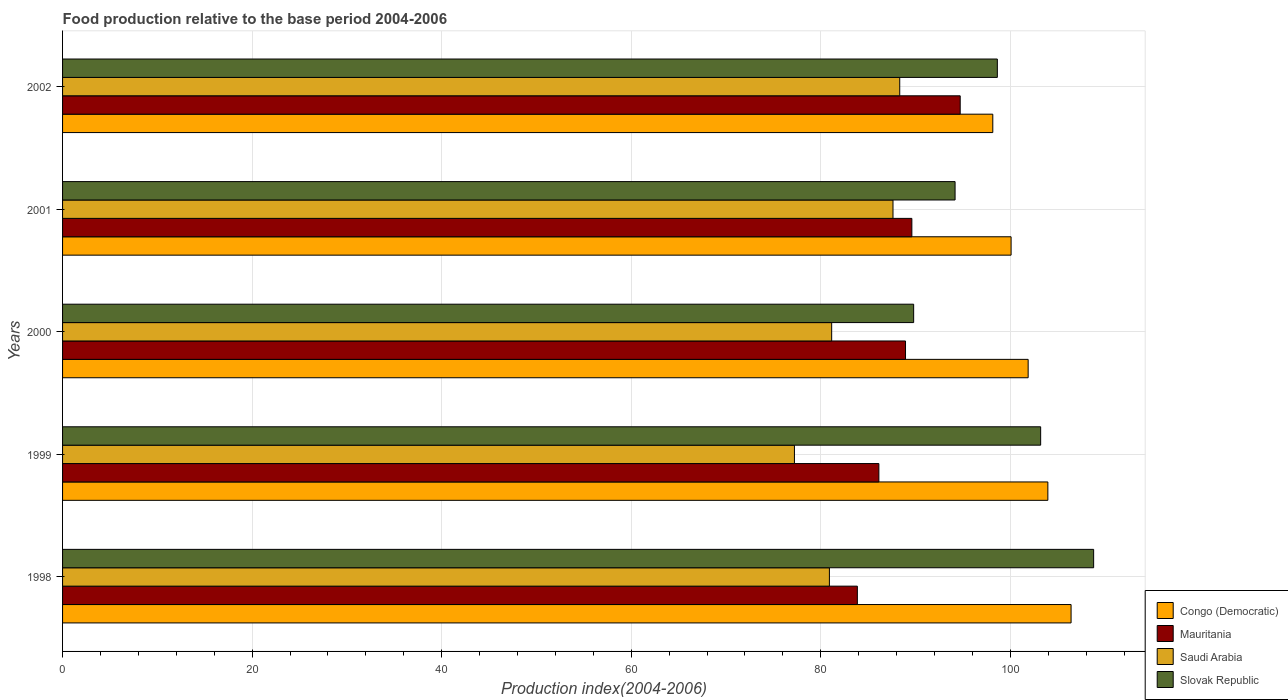Are the number of bars per tick equal to the number of legend labels?
Give a very brief answer. Yes. Are the number of bars on each tick of the Y-axis equal?
Your response must be concise. Yes. What is the label of the 4th group of bars from the top?
Offer a terse response. 1999. What is the food production index in Mauritania in 2000?
Your answer should be compact. 88.94. Across all years, what is the maximum food production index in Congo (Democratic)?
Ensure brevity in your answer.  106.41. Across all years, what is the minimum food production index in Mauritania?
Your answer should be very brief. 83.86. In which year was the food production index in Mauritania maximum?
Provide a succinct answer. 2002. What is the total food production index in Slovak Republic in the graph?
Keep it short and to the point. 494.59. What is the difference between the food production index in Saudi Arabia in 1999 and that in 2000?
Ensure brevity in your answer.  -3.93. What is the difference between the food production index in Slovak Republic in 2001 and the food production index in Mauritania in 1999?
Provide a succinct answer. 8.04. What is the average food production index in Mauritania per year?
Your answer should be very brief. 88.65. In the year 2002, what is the difference between the food production index in Congo (Democratic) and food production index in Slovak Republic?
Make the answer very short. -0.48. What is the ratio of the food production index in Mauritania in 1999 to that in 2000?
Make the answer very short. 0.97. Is the food production index in Mauritania in 1999 less than that in 2000?
Your response must be concise. Yes. What is the difference between the highest and the second highest food production index in Congo (Democratic)?
Your answer should be very brief. 2.45. What is the difference between the highest and the lowest food production index in Mauritania?
Make the answer very short. 10.85. Is the sum of the food production index in Slovak Republic in 2000 and 2001 greater than the maximum food production index in Saudi Arabia across all years?
Make the answer very short. Yes. What does the 3rd bar from the top in 2001 represents?
Make the answer very short. Mauritania. What does the 3rd bar from the bottom in 2002 represents?
Your answer should be compact. Saudi Arabia. Is it the case that in every year, the sum of the food production index in Saudi Arabia and food production index in Mauritania is greater than the food production index in Slovak Republic?
Ensure brevity in your answer.  Yes. How many bars are there?
Ensure brevity in your answer.  20. How many years are there in the graph?
Offer a very short reply. 5. What is the difference between two consecutive major ticks on the X-axis?
Offer a terse response. 20. Does the graph contain grids?
Offer a terse response. Yes. Where does the legend appear in the graph?
Give a very brief answer. Bottom right. How are the legend labels stacked?
Keep it short and to the point. Vertical. What is the title of the graph?
Provide a succinct answer. Food production relative to the base period 2004-2006. What is the label or title of the X-axis?
Your answer should be compact. Production index(2004-2006). What is the label or title of the Y-axis?
Your response must be concise. Years. What is the Production index(2004-2006) in Congo (Democratic) in 1998?
Offer a very short reply. 106.41. What is the Production index(2004-2006) in Mauritania in 1998?
Keep it short and to the point. 83.86. What is the Production index(2004-2006) of Saudi Arabia in 1998?
Give a very brief answer. 80.91. What is the Production index(2004-2006) in Slovak Republic in 1998?
Give a very brief answer. 108.79. What is the Production index(2004-2006) in Congo (Democratic) in 1999?
Keep it short and to the point. 103.96. What is the Production index(2004-2006) in Mauritania in 1999?
Offer a terse response. 86.13. What is the Production index(2004-2006) in Saudi Arabia in 1999?
Your response must be concise. 77.22. What is the Production index(2004-2006) in Slovak Republic in 1999?
Provide a succinct answer. 103.2. What is the Production index(2004-2006) of Congo (Democratic) in 2000?
Your answer should be compact. 101.88. What is the Production index(2004-2006) of Mauritania in 2000?
Keep it short and to the point. 88.94. What is the Production index(2004-2006) of Saudi Arabia in 2000?
Offer a very short reply. 81.15. What is the Production index(2004-2006) of Slovak Republic in 2000?
Your answer should be very brief. 89.8. What is the Production index(2004-2006) in Congo (Democratic) in 2001?
Provide a succinct answer. 100.08. What is the Production index(2004-2006) of Mauritania in 2001?
Ensure brevity in your answer.  89.61. What is the Production index(2004-2006) in Saudi Arabia in 2001?
Provide a succinct answer. 87.62. What is the Production index(2004-2006) of Slovak Republic in 2001?
Your answer should be compact. 94.17. What is the Production index(2004-2006) in Congo (Democratic) in 2002?
Give a very brief answer. 98.15. What is the Production index(2004-2006) in Mauritania in 2002?
Keep it short and to the point. 94.71. What is the Production index(2004-2006) of Saudi Arabia in 2002?
Offer a very short reply. 88.33. What is the Production index(2004-2006) of Slovak Republic in 2002?
Your response must be concise. 98.63. Across all years, what is the maximum Production index(2004-2006) in Congo (Democratic)?
Offer a terse response. 106.41. Across all years, what is the maximum Production index(2004-2006) of Mauritania?
Ensure brevity in your answer.  94.71. Across all years, what is the maximum Production index(2004-2006) of Saudi Arabia?
Your answer should be very brief. 88.33. Across all years, what is the maximum Production index(2004-2006) in Slovak Republic?
Ensure brevity in your answer.  108.79. Across all years, what is the minimum Production index(2004-2006) in Congo (Democratic)?
Offer a terse response. 98.15. Across all years, what is the minimum Production index(2004-2006) in Mauritania?
Ensure brevity in your answer.  83.86. Across all years, what is the minimum Production index(2004-2006) in Saudi Arabia?
Your response must be concise. 77.22. Across all years, what is the minimum Production index(2004-2006) in Slovak Republic?
Provide a succinct answer. 89.8. What is the total Production index(2004-2006) in Congo (Democratic) in the graph?
Make the answer very short. 510.48. What is the total Production index(2004-2006) of Mauritania in the graph?
Offer a very short reply. 443.25. What is the total Production index(2004-2006) of Saudi Arabia in the graph?
Provide a succinct answer. 415.23. What is the total Production index(2004-2006) in Slovak Republic in the graph?
Your answer should be very brief. 494.59. What is the difference between the Production index(2004-2006) of Congo (Democratic) in 1998 and that in 1999?
Offer a very short reply. 2.45. What is the difference between the Production index(2004-2006) in Mauritania in 1998 and that in 1999?
Your answer should be very brief. -2.27. What is the difference between the Production index(2004-2006) of Saudi Arabia in 1998 and that in 1999?
Your response must be concise. 3.69. What is the difference between the Production index(2004-2006) in Slovak Republic in 1998 and that in 1999?
Ensure brevity in your answer.  5.59. What is the difference between the Production index(2004-2006) of Congo (Democratic) in 1998 and that in 2000?
Offer a terse response. 4.53. What is the difference between the Production index(2004-2006) in Mauritania in 1998 and that in 2000?
Offer a terse response. -5.08. What is the difference between the Production index(2004-2006) of Saudi Arabia in 1998 and that in 2000?
Offer a terse response. -0.24. What is the difference between the Production index(2004-2006) of Slovak Republic in 1998 and that in 2000?
Provide a succinct answer. 18.99. What is the difference between the Production index(2004-2006) of Congo (Democratic) in 1998 and that in 2001?
Your response must be concise. 6.33. What is the difference between the Production index(2004-2006) in Mauritania in 1998 and that in 2001?
Provide a succinct answer. -5.75. What is the difference between the Production index(2004-2006) of Saudi Arabia in 1998 and that in 2001?
Ensure brevity in your answer.  -6.71. What is the difference between the Production index(2004-2006) of Slovak Republic in 1998 and that in 2001?
Keep it short and to the point. 14.62. What is the difference between the Production index(2004-2006) of Congo (Democratic) in 1998 and that in 2002?
Ensure brevity in your answer.  8.26. What is the difference between the Production index(2004-2006) of Mauritania in 1998 and that in 2002?
Give a very brief answer. -10.85. What is the difference between the Production index(2004-2006) in Saudi Arabia in 1998 and that in 2002?
Offer a terse response. -7.42. What is the difference between the Production index(2004-2006) in Slovak Republic in 1998 and that in 2002?
Give a very brief answer. 10.16. What is the difference between the Production index(2004-2006) of Congo (Democratic) in 1999 and that in 2000?
Offer a very short reply. 2.08. What is the difference between the Production index(2004-2006) in Mauritania in 1999 and that in 2000?
Your response must be concise. -2.81. What is the difference between the Production index(2004-2006) of Saudi Arabia in 1999 and that in 2000?
Give a very brief answer. -3.93. What is the difference between the Production index(2004-2006) in Congo (Democratic) in 1999 and that in 2001?
Offer a very short reply. 3.88. What is the difference between the Production index(2004-2006) in Mauritania in 1999 and that in 2001?
Offer a very short reply. -3.48. What is the difference between the Production index(2004-2006) in Saudi Arabia in 1999 and that in 2001?
Offer a terse response. -10.4. What is the difference between the Production index(2004-2006) of Slovak Republic in 1999 and that in 2001?
Keep it short and to the point. 9.03. What is the difference between the Production index(2004-2006) of Congo (Democratic) in 1999 and that in 2002?
Provide a short and direct response. 5.81. What is the difference between the Production index(2004-2006) of Mauritania in 1999 and that in 2002?
Your response must be concise. -8.58. What is the difference between the Production index(2004-2006) of Saudi Arabia in 1999 and that in 2002?
Keep it short and to the point. -11.11. What is the difference between the Production index(2004-2006) in Slovak Republic in 1999 and that in 2002?
Give a very brief answer. 4.57. What is the difference between the Production index(2004-2006) in Mauritania in 2000 and that in 2001?
Your answer should be very brief. -0.67. What is the difference between the Production index(2004-2006) of Saudi Arabia in 2000 and that in 2001?
Offer a very short reply. -6.47. What is the difference between the Production index(2004-2006) in Slovak Republic in 2000 and that in 2001?
Give a very brief answer. -4.37. What is the difference between the Production index(2004-2006) in Congo (Democratic) in 2000 and that in 2002?
Offer a terse response. 3.73. What is the difference between the Production index(2004-2006) in Mauritania in 2000 and that in 2002?
Offer a very short reply. -5.77. What is the difference between the Production index(2004-2006) in Saudi Arabia in 2000 and that in 2002?
Offer a very short reply. -7.18. What is the difference between the Production index(2004-2006) in Slovak Republic in 2000 and that in 2002?
Your answer should be very brief. -8.83. What is the difference between the Production index(2004-2006) in Congo (Democratic) in 2001 and that in 2002?
Your answer should be very brief. 1.93. What is the difference between the Production index(2004-2006) of Saudi Arabia in 2001 and that in 2002?
Provide a succinct answer. -0.71. What is the difference between the Production index(2004-2006) in Slovak Republic in 2001 and that in 2002?
Ensure brevity in your answer.  -4.46. What is the difference between the Production index(2004-2006) in Congo (Democratic) in 1998 and the Production index(2004-2006) in Mauritania in 1999?
Provide a short and direct response. 20.28. What is the difference between the Production index(2004-2006) of Congo (Democratic) in 1998 and the Production index(2004-2006) of Saudi Arabia in 1999?
Offer a terse response. 29.19. What is the difference between the Production index(2004-2006) in Congo (Democratic) in 1998 and the Production index(2004-2006) in Slovak Republic in 1999?
Ensure brevity in your answer.  3.21. What is the difference between the Production index(2004-2006) in Mauritania in 1998 and the Production index(2004-2006) in Saudi Arabia in 1999?
Offer a very short reply. 6.64. What is the difference between the Production index(2004-2006) in Mauritania in 1998 and the Production index(2004-2006) in Slovak Republic in 1999?
Offer a terse response. -19.34. What is the difference between the Production index(2004-2006) of Saudi Arabia in 1998 and the Production index(2004-2006) of Slovak Republic in 1999?
Your answer should be very brief. -22.29. What is the difference between the Production index(2004-2006) of Congo (Democratic) in 1998 and the Production index(2004-2006) of Mauritania in 2000?
Provide a succinct answer. 17.47. What is the difference between the Production index(2004-2006) in Congo (Democratic) in 1998 and the Production index(2004-2006) in Saudi Arabia in 2000?
Provide a short and direct response. 25.26. What is the difference between the Production index(2004-2006) of Congo (Democratic) in 1998 and the Production index(2004-2006) of Slovak Republic in 2000?
Provide a short and direct response. 16.61. What is the difference between the Production index(2004-2006) in Mauritania in 1998 and the Production index(2004-2006) in Saudi Arabia in 2000?
Your answer should be compact. 2.71. What is the difference between the Production index(2004-2006) of Mauritania in 1998 and the Production index(2004-2006) of Slovak Republic in 2000?
Offer a terse response. -5.94. What is the difference between the Production index(2004-2006) of Saudi Arabia in 1998 and the Production index(2004-2006) of Slovak Republic in 2000?
Offer a very short reply. -8.89. What is the difference between the Production index(2004-2006) of Congo (Democratic) in 1998 and the Production index(2004-2006) of Mauritania in 2001?
Provide a short and direct response. 16.8. What is the difference between the Production index(2004-2006) in Congo (Democratic) in 1998 and the Production index(2004-2006) in Saudi Arabia in 2001?
Offer a terse response. 18.79. What is the difference between the Production index(2004-2006) in Congo (Democratic) in 1998 and the Production index(2004-2006) in Slovak Republic in 2001?
Offer a very short reply. 12.24. What is the difference between the Production index(2004-2006) in Mauritania in 1998 and the Production index(2004-2006) in Saudi Arabia in 2001?
Provide a short and direct response. -3.76. What is the difference between the Production index(2004-2006) in Mauritania in 1998 and the Production index(2004-2006) in Slovak Republic in 2001?
Your answer should be compact. -10.31. What is the difference between the Production index(2004-2006) of Saudi Arabia in 1998 and the Production index(2004-2006) of Slovak Republic in 2001?
Keep it short and to the point. -13.26. What is the difference between the Production index(2004-2006) of Congo (Democratic) in 1998 and the Production index(2004-2006) of Saudi Arabia in 2002?
Give a very brief answer. 18.08. What is the difference between the Production index(2004-2006) of Congo (Democratic) in 1998 and the Production index(2004-2006) of Slovak Republic in 2002?
Keep it short and to the point. 7.78. What is the difference between the Production index(2004-2006) in Mauritania in 1998 and the Production index(2004-2006) in Saudi Arabia in 2002?
Provide a short and direct response. -4.47. What is the difference between the Production index(2004-2006) of Mauritania in 1998 and the Production index(2004-2006) of Slovak Republic in 2002?
Offer a terse response. -14.77. What is the difference between the Production index(2004-2006) in Saudi Arabia in 1998 and the Production index(2004-2006) in Slovak Republic in 2002?
Your answer should be very brief. -17.72. What is the difference between the Production index(2004-2006) in Congo (Democratic) in 1999 and the Production index(2004-2006) in Mauritania in 2000?
Give a very brief answer. 15.02. What is the difference between the Production index(2004-2006) in Congo (Democratic) in 1999 and the Production index(2004-2006) in Saudi Arabia in 2000?
Ensure brevity in your answer.  22.81. What is the difference between the Production index(2004-2006) in Congo (Democratic) in 1999 and the Production index(2004-2006) in Slovak Republic in 2000?
Give a very brief answer. 14.16. What is the difference between the Production index(2004-2006) in Mauritania in 1999 and the Production index(2004-2006) in Saudi Arabia in 2000?
Keep it short and to the point. 4.98. What is the difference between the Production index(2004-2006) of Mauritania in 1999 and the Production index(2004-2006) of Slovak Republic in 2000?
Your answer should be compact. -3.67. What is the difference between the Production index(2004-2006) in Saudi Arabia in 1999 and the Production index(2004-2006) in Slovak Republic in 2000?
Make the answer very short. -12.58. What is the difference between the Production index(2004-2006) of Congo (Democratic) in 1999 and the Production index(2004-2006) of Mauritania in 2001?
Offer a very short reply. 14.35. What is the difference between the Production index(2004-2006) of Congo (Democratic) in 1999 and the Production index(2004-2006) of Saudi Arabia in 2001?
Your answer should be compact. 16.34. What is the difference between the Production index(2004-2006) in Congo (Democratic) in 1999 and the Production index(2004-2006) in Slovak Republic in 2001?
Your response must be concise. 9.79. What is the difference between the Production index(2004-2006) in Mauritania in 1999 and the Production index(2004-2006) in Saudi Arabia in 2001?
Your response must be concise. -1.49. What is the difference between the Production index(2004-2006) of Mauritania in 1999 and the Production index(2004-2006) of Slovak Republic in 2001?
Your response must be concise. -8.04. What is the difference between the Production index(2004-2006) in Saudi Arabia in 1999 and the Production index(2004-2006) in Slovak Republic in 2001?
Give a very brief answer. -16.95. What is the difference between the Production index(2004-2006) of Congo (Democratic) in 1999 and the Production index(2004-2006) of Mauritania in 2002?
Make the answer very short. 9.25. What is the difference between the Production index(2004-2006) in Congo (Democratic) in 1999 and the Production index(2004-2006) in Saudi Arabia in 2002?
Give a very brief answer. 15.63. What is the difference between the Production index(2004-2006) of Congo (Democratic) in 1999 and the Production index(2004-2006) of Slovak Republic in 2002?
Keep it short and to the point. 5.33. What is the difference between the Production index(2004-2006) in Mauritania in 1999 and the Production index(2004-2006) in Slovak Republic in 2002?
Your answer should be compact. -12.5. What is the difference between the Production index(2004-2006) in Saudi Arabia in 1999 and the Production index(2004-2006) in Slovak Republic in 2002?
Give a very brief answer. -21.41. What is the difference between the Production index(2004-2006) of Congo (Democratic) in 2000 and the Production index(2004-2006) of Mauritania in 2001?
Ensure brevity in your answer.  12.27. What is the difference between the Production index(2004-2006) of Congo (Democratic) in 2000 and the Production index(2004-2006) of Saudi Arabia in 2001?
Provide a succinct answer. 14.26. What is the difference between the Production index(2004-2006) of Congo (Democratic) in 2000 and the Production index(2004-2006) of Slovak Republic in 2001?
Keep it short and to the point. 7.71. What is the difference between the Production index(2004-2006) in Mauritania in 2000 and the Production index(2004-2006) in Saudi Arabia in 2001?
Your response must be concise. 1.32. What is the difference between the Production index(2004-2006) of Mauritania in 2000 and the Production index(2004-2006) of Slovak Republic in 2001?
Provide a short and direct response. -5.23. What is the difference between the Production index(2004-2006) of Saudi Arabia in 2000 and the Production index(2004-2006) of Slovak Republic in 2001?
Offer a very short reply. -13.02. What is the difference between the Production index(2004-2006) in Congo (Democratic) in 2000 and the Production index(2004-2006) in Mauritania in 2002?
Offer a terse response. 7.17. What is the difference between the Production index(2004-2006) of Congo (Democratic) in 2000 and the Production index(2004-2006) of Saudi Arabia in 2002?
Make the answer very short. 13.55. What is the difference between the Production index(2004-2006) of Mauritania in 2000 and the Production index(2004-2006) of Saudi Arabia in 2002?
Make the answer very short. 0.61. What is the difference between the Production index(2004-2006) of Mauritania in 2000 and the Production index(2004-2006) of Slovak Republic in 2002?
Offer a very short reply. -9.69. What is the difference between the Production index(2004-2006) of Saudi Arabia in 2000 and the Production index(2004-2006) of Slovak Republic in 2002?
Ensure brevity in your answer.  -17.48. What is the difference between the Production index(2004-2006) in Congo (Democratic) in 2001 and the Production index(2004-2006) in Mauritania in 2002?
Give a very brief answer. 5.37. What is the difference between the Production index(2004-2006) of Congo (Democratic) in 2001 and the Production index(2004-2006) of Saudi Arabia in 2002?
Make the answer very short. 11.75. What is the difference between the Production index(2004-2006) in Congo (Democratic) in 2001 and the Production index(2004-2006) in Slovak Republic in 2002?
Provide a succinct answer. 1.45. What is the difference between the Production index(2004-2006) of Mauritania in 2001 and the Production index(2004-2006) of Saudi Arabia in 2002?
Keep it short and to the point. 1.28. What is the difference between the Production index(2004-2006) of Mauritania in 2001 and the Production index(2004-2006) of Slovak Republic in 2002?
Your answer should be very brief. -9.02. What is the difference between the Production index(2004-2006) in Saudi Arabia in 2001 and the Production index(2004-2006) in Slovak Republic in 2002?
Ensure brevity in your answer.  -11.01. What is the average Production index(2004-2006) of Congo (Democratic) per year?
Your answer should be compact. 102.1. What is the average Production index(2004-2006) of Mauritania per year?
Make the answer very short. 88.65. What is the average Production index(2004-2006) in Saudi Arabia per year?
Your response must be concise. 83.05. What is the average Production index(2004-2006) of Slovak Republic per year?
Make the answer very short. 98.92. In the year 1998, what is the difference between the Production index(2004-2006) in Congo (Democratic) and Production index(2004-2006) in Mauritania?
Offer a very short reply. 22.55. In the year 1998, what is the difference between the Production index(2004-2006) of Congo (Democratic) and Production index(2004-2006) of Saudi Arabia?
Make the answer very short. 25.5. In the year 1998, what is the difference between the Production index(2004-2006) of Congo (Democratic) and Production index(2004-2006) of Slovak Republic?
Provide a succinct answer. -2.38. In the year 1998, what is the difference between the Production index(2004-2006) in Mauritania and Production index(2004-2006) in Saudi Arabia?
Your answer should be compact. 2.95. In the year 1998, what is the difference between the Production index(2004-2006) in Mauritania and Production index(2004-2006) in Slovak Republic?
Give a very brief answer. -24.93. In the year 1998, what is the difference between the Production index(2004-2006) in Saudi Arabia and Production index(2004-2006) in Slovak Republic?
Keep it short and to the point. -27.88. In the year 1999, what is the difference between the Production index(2004-2006) in Congo (Democratic) and Production index(2004-2006) in Mauritania?
Offer a very short reply. 17.83. In the year 1999, what is the difference between the Production index(2004-2006) in Congo (Democratic) and Production index(2004-2006) in Saudi Arabia?
Your answer should be compact. 26.74. In the year 1999, what is the difference between the Production index(2004-2006) of Congo (Democratic) and Production index(2004-2006) of Slovak Republic?
Your answer should be compact. 0.76. In the year 1999, what is the difference between the Production index(2004-2006) of Mauritania and Production index(2004-2006) of Saudi Arabia?
Your answer should be compact. 8.91. In the year 1999, what is the difference between the Production index(2004-2006) in Mauritania and Production index(2004-2006) in Slovak Republic?
Ensure brevity in your answer.  -17.07. In the year 1999, what is the difference between the Production index(2004-2006) of Saudi Arabia and Production index(2004-2006) of Slovak Republic?
Your answer should be compact. -25.98. In the year 2000, what is the difference between the Production index(2004-2006) in Congo (Democratic) and Production index(2004-2006) in Mauritania?
Your response must be concise. 12.94. In the year 2000, what is the difference between the Production index(2004-2006) in Congo (Democratic) and Production index(2004-2006) in Saudi Arabia?
Make the answer very short. 20.73. In the year 2000, what is the difference between the Production index(2004-2006) of Congo (Democratic) and Production index(2004-2006) of Slovak Republic?
Offer a terse response. 12.08. In the year 2000, what is the difference between the Production index(2004-2006) of Mauritania and Production index(2004-2006) of Saudi Arabia?
Give a very brief answer. 7.79. In the year 2000, what is the difference between the Production index(2004-2006) of Mauritania and Production index(2004-2006) of Slovak Republic?
Provide a short and direct response. -0.86. In the year 2000, what is the difference between the Production index(2004-2006) in Saudi Arabia and Production index(2004-2006) in Slovak Republic?
Offer a very short reply. -8.65. In the year 2001, what is the difference between the Production index(2004-2006) in Congo (Democratic) and Production index(2004-2006) in Mauritania?
Ensure brevity in your answer.  10.47. In the year 2001, what is the difference between the Production index(2004-2006) of Congo (Democratic) and Production index(2004-2006) of Saudi Arabia?
Ensure brevity in your answer.  12.46. In the year 2001, what is the difference between the Production index(2004-2006) in Congo (Democratic) and Production index(2004-2006) in Slovak Republic?
Keep it short and to the point. 5.91. In the year 2001, what is the difference between the Production index(2004-2006) of Mauritania and Production index(2004-2006) of Saudi Arabia?
Make the answer very short. 1.99. In the year 2001, what is the difference between the Production index(2004-2006) in Mauritania and Production index(2004-2006) in Slovak Republic?
Offer a very short reply. -4.56. In the year 2001, what is the difference between the Production index(2004-2006) of Saudi Arabia and Production index(2004-2006) of Slovak Republic?
Keep it short and to the point. -6.55. In the year 2002, what is the difference between the Production index(2004-2006) of Congo (Democratic) and Production index(2004-2006) of Mauritania?
Your answer should be compact. 3.44. In the year 2002, what is the difference between the Production index(2004-2006) in Congo (Democratic) and Production index(2004-2006) in Saudi Arabia?
Make the answer very short. 9.82. In the year 2002, what is the difference between the Production index(2004-2006) of Congo (Democratic) and Production index(2004-2006) of Slovak Republic?
Offer a very short reply. -0.48. In the year 2002, what is the difference between the Production index(2004-2006) of Mauritania and Production index(2004-2006) of Saudi Arabia?
Provide a short and direct response. 6.38. In the year 2002, what is the difference between the Production index(2004-2006) of Mauritania and Production index(2004-2006) of Slovak Republic?
Your response must be concise. -3.92. What is the ratio of the Production index(2004-2006) of Congo (Democratic) in 1998 to that in 1999?
Ensure brevity in your answer.  1.02. What is the ratio of the Production index(2004-2006) in Mauritania in 1998 to that in 1999?
Ensure brevity in your answer.  0.97. What is the ratio of the Production index(2004-2006) in Saudi Arabia in 1998 to that in 1999?
Offer a terse response. 1.05. What is the ratio of the Production index(2004-2006) in Slovak Republic in 1998 to that in 1999?
Give a very brief answer. 1.05. What is the ratio of the Production index(2004-2006) in Congo (Democratic) in 1998 to that in 2000?
Ensure brevity in your answer.  1.04. What is the ratio of the Production index(2004-2006) of Mauritania in 1998 to that in 2000?
Ensure brevity in your answer.  0.94. What is the ratio of the Production index(2004-2006) in Saudi Arabia in 1998 to that in 2000?
Offer a terse response. 1. What is the ratio of the Production index(2004-2006) in Slovak Republic in 1998 to that in 2000?
Your response must be concise. 1.21. What is the ratio of the Production index(2004-2006) of Congo (Democratic) in 1998 to that in 2001?
Offer a very short reply. 1.06. What is the ratio of the Production index(2004-2006) in Mauritania in 1998 to that in 2001?
Your answer should be very brief. 0.94. What is the ratio of the Production index(2004-2006) of Saudi Arabia in 1998 to that in 2001?
Provide a short and direct response. 0.92. What is the ratio of the Production index(2004-2006) in Slovak Republic in 1998 to that in 2001?
Make the answer very short. 1.16. What is the ratio of the Production index(2004-2006) of Congo (Democratic) in 1998 to that in 2002?
Your answer should be very brief. 1.08. What is the ratio of the Production index(2004-2006) of Mauritania in 1998 to that in 2002?
Make the answer very short. 0.89. What is the ratio of the Production index(2004-2006) of Saudi Arabia in 1998 to that in 2002?
Your response must be concise. 0.92. What is the ratio of the Production index(2004-2006) in Slovak Republic in 1998 to that in 2002?
Your answer should be very brief. 1.1. What is the ratio of the Production index(2004-2006) of Congo (Democratic) in 1999 to that in 2000?
Your answer should be compact. 1.02. What is the ratio of the Production index(2004-2006) in Mauritania in 1999 to that in 2000?
Keep it short and to the point. 0.97. What is the ratio of the Production index(2004-2006) in Saudi Arabia in 1999 to that in 2000?
Give a very brief answer. 0.95. What is the ratio of the Production index(2004-2006) of Slovak Republic in 1999 to that in 2000?
Keep it short and to the point. 1.15. What is the ratio of the Production index(2004-2006) in Congo (Democratic) in 1999 to that in 2001?
Keep it short and to the point. 1.04. What is the ratio of the Production index(2004-2006) of Mauritania in 1999 to that in 2001?
Keep it short and to the point. 0.96. What is the ratio of the Production index(2004-2006) in Saudi Arabia in 1999 to that in 2001?
Make the answer very short. 0.88. What is the ratio of the Production index(2004-2006) of Slovak Republic in 1999 to that in 2001?
Your response must be concise. 1.1. What is the ratio of the Production index(2004-2006) in Congo (Democratic) in 1999 to that in 2002?
Your answer should be very brief. 1.06. What is the ratio of the Production index(2004-2006) of Mauritania in 1999 to that in 2002?
Give a very brief answer. 0.91. What is the ratio of the Production index(2004-2006) of Saudi Arabia in 1999 to that in 2002?
Provide a succinct answer. 0.87. What is the ratio of the Production index(2004-2006) of Slovak Republic in 1999 to that in 2002?
Make the answer very short. 1.05. What is the ratio of the Production index(2004-2006) in Saudi Arabia in 2000 to that in 2001?
Your answer should be very brief. 0.93. What is the ratio of the Production index(2004-2006) in Slovak Republic in 2000 to that in 2001?
Provide a short and direct response. 0.95. What is the ratio of the Production index(2004-2006) in Congo (Democratic) in 2000 to that in 2002?
Provide a short and direct response. 1.04. What is the ratio of the Production index(2004-2006) in Mauritania in 2000 to that in 2002?
Keep it short and to the point. 0.94. What is the ratio of the Production index(2004-2006) of Saudi Arabia in 2000 to that in 2002?
Your answer should be very brief. 0.92. What is the ratio of the Production index(2004-2006) in Slovak Republic in 2000 to that in 2002?
Offer a very short reply. 0.91. What is the ratio of the Production index(2004-2006) of Congo (Democratic) in 2001 to that in 2002?
Make the answer very short. 1.02. What is the ratio of the Production index(2004-2006) of Mauritania in 2001 to that in 2002?
Offer a terse response. 0.95. What is the ratio of the Production index(2004-2006) of Slovak Republic in 2001 to that in 2002?
Offer a very short reply. 0.95. What is the difference between the highest and the second highest Production index(2004-2006) of Congo (Democratic)?
Keep it short and to the point. 2.45. What is the difference between the highest and the second highest Production index(2004-2006) in Saudi Arabia?
Offer a terse response. 0.71. What is the difference between the highest and the second highest Production index(2004-2006) in Slovak Republic?
Ensure brevity in your answer.  5.59. What is the difference between the highest and the lowest Production index(2004-2006) of Congo (Democratic)?
Ensure brevity in your answer.  8.26. What is the difference between the highest and the lowest Production index(2004-2006) in Mauritania?
Your answer should be very brief. 10.85. What is the difference between the highest and the lowest Production index(2004-2006) of Saudi Arabia?
Provide a succinct answer. 11.11. What is the difference between the highest and the lowest Production index(2004-2006) of Slovak Republic?
Your answer should be very brief. 18.99. 